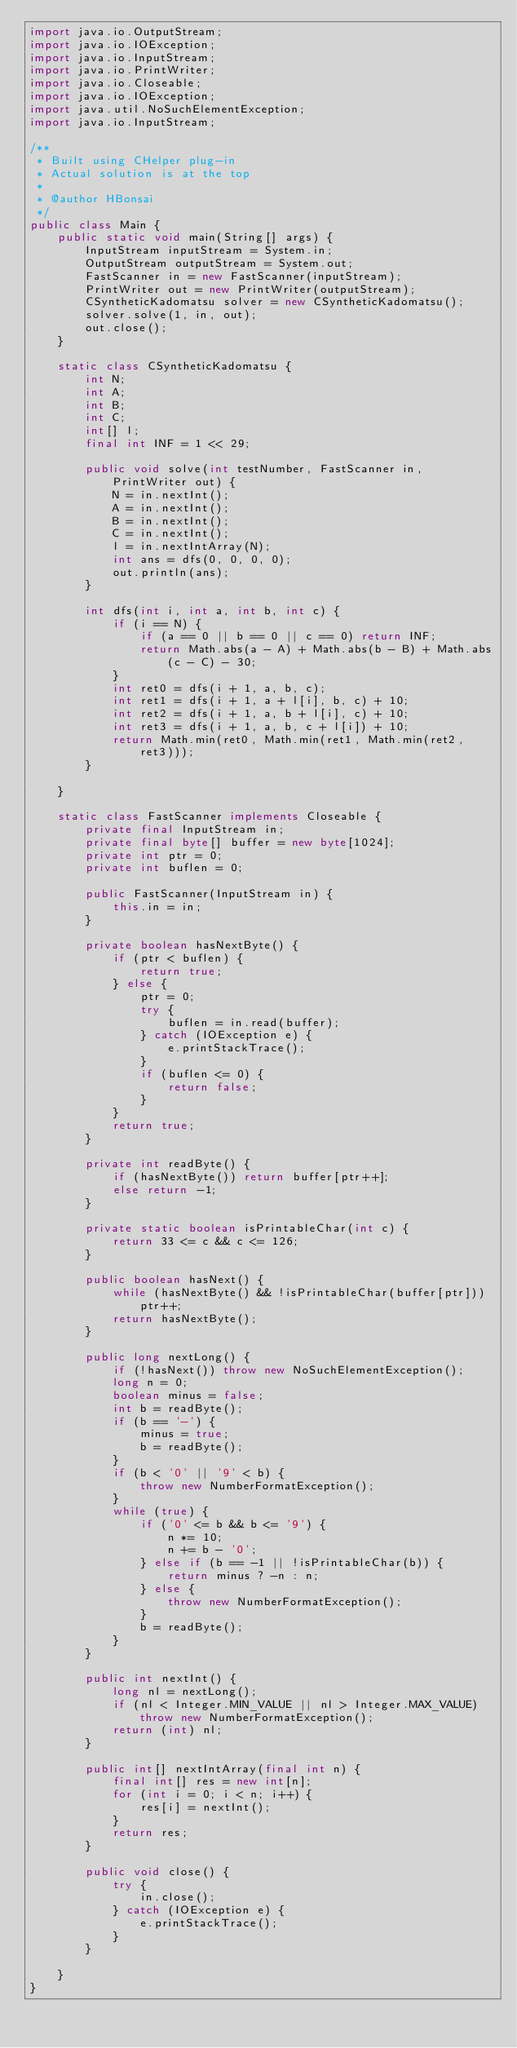Convert code to text. <code><loc_0><loc_0><loc_500><loc_500><_Java_>import java.io.OutputStream;
import java.io.IOException;
import java.io.InputStream;
import java.io.PrintWriter;
import java.io.Closeable;
import java.io.IOException;
import java.util.NoSuchElementException;
import java.io.InputStream;

/**
 * Built using CHelper plug-in
 * Actual solution is at the top
 *
 * @author HBonsai
 */
public class Main {
    public static void main(String[] args) {
        InputStream inputStream = System.in;
        OutputStream outputStream = System.out;
        FastScanner in = new FastScanner(inputStream);
        PrintWriter out = new PrintWriter(outputStream);
        CSyntheticKadomatsu solver = new CSyntheticKadomatsu();
        solver.solve(1, in, out);
        out.close();
    }

    static class CSyntheticKadomatsu {
        int N;
        int A;
        int B;
        int C;
        int[] l;
        final int INF = 1 << 29;

        public void solve(int testNumber, FastScanner in, PrintWriter out) {
            N = in.nextInt();
            A = in.nextInt();
            B = in.nextInt();
            C = in.nextInt();
            l = in.nextIntArray(N);
            int ans = dfs(0, 0, 0, 0);
            out.println(ans);
        }

        int dfs(int i, int a, int b, int c) {
            if (i == N) {
                if (a == 0 || b == 0 || c == 0) return INF;
                return Math.abs(a - A) + Math.abs(b - B) + Math.abs(c - C) - 30;
            }
            int ret0 = dfs(i + 1, a, b, c);
            int ret1 = dfs(i + 1, a + l[i], b, c) + 10;
            int ret2 = dfs(i + 1, a, b + l[i], c) + 10;
            int ret3 = dfs(i + 1, a, b, c + l[i]) + 10;
            return Math.min(ret0, Math.min(ret1, Math.min(ret2, ret3)));
        }

    }

    static class FastScanner implements Closeable {
        private final InputStream in;
        private final byte[] buffer = new byte[1024];
        private int ptr = 0;
        private int buflen = 0;

        public FastScanner(InputStream in) {
            this.in = in;
        }

        private boolean hasNextByte() {
            if (ptr < buflen) {
                return true;
            } else {
                ptr = 0;
                try {
                    buflen = in.read(buffer);
                } catch (IOException e) {
                    e.printStackTrace();
                }
                if (buflen <= 0) {
                    return false;
                }
            }
            return true;
        }

        private int readByte() {
            if (hasNextByte()) return buffer[ptr++];
            else return -1;
        }

        private static boolean isPrintableChar(int c) {
            return 33 <= c && c <= 126;
        }

        public boolean hasNext() {
            while (hasNextByte() && !isPrintableChar(buffer[ptr])) ptr++;
            return hasNextByte();
        }

        public long nextLong() {
            if (!hasNext()) throw new NoSuchElementException();
            long n = 0;
            boolean minus = false;
            int b = readByte();
            if (b == '-') {
                minus = true;
                b = readByte();
            }
            if (b < '0' || '9' < b) {
                throw new NumberFormatException();
            }
            while (true) {
                if ('0' <= b && b <= '9') {
                    n *= 10;
                    n += b - '0';
                } else if (b == -1 || !isPrintableChar(b)) {
                    return minus ? -n : n;
                } else {
                    throw new NumberFormatException();
                }
                b = readByte();
            }
        }

        public int nextInt() {
            long nl = nextLong();
            if (nl < Integer.MIN_VALUE || nl > Integer.MAX_VALUE) throw new NumberFormatException();
            return (int) nl;
        }

        public int[] nextIntArray(final int n) {
            final int[] res = new int[n];
            for (int i = 0; i < n; i++) {
                res[i] = nextInt();
            }
            return res;
        }

        public void close() {
            try {
                in.close();
            } catch (IOException e) {
                e.printStackTrace();
            }
        }

    }
}

</code> 